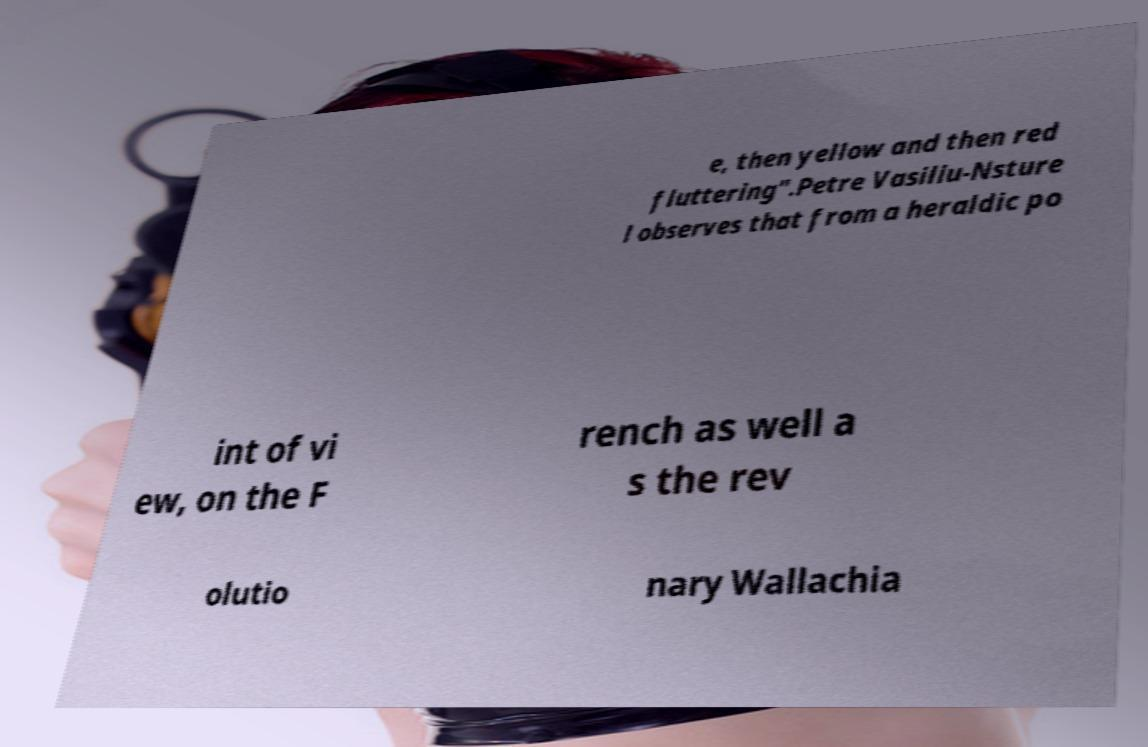Please read and relay the text visible in this image. What does it say? e, then yellow and then red fluttering".Petre Vasiliu-Nsture l observes that from a heraldic po int of vi ew, on the F rench as well a s the rev olutio nary Wallachia 